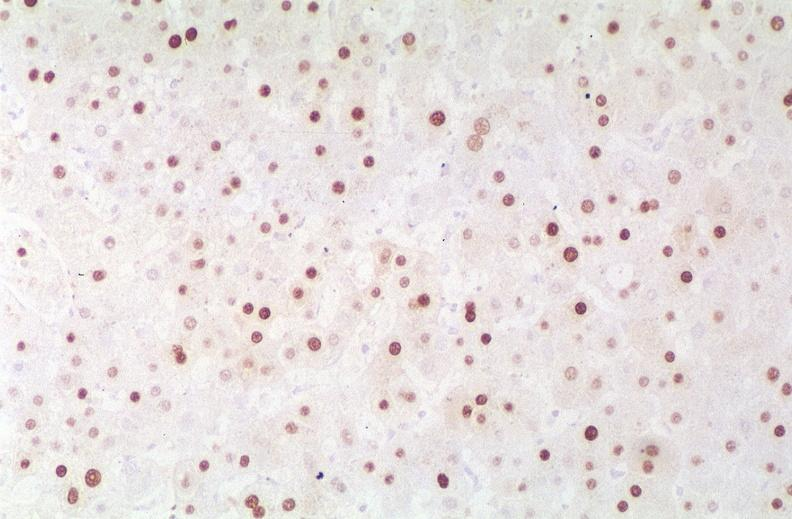does this image show hepatitis b virus, hbve antigen immunohistochemistry?
Answer the question using a single word or phrase. Yes 